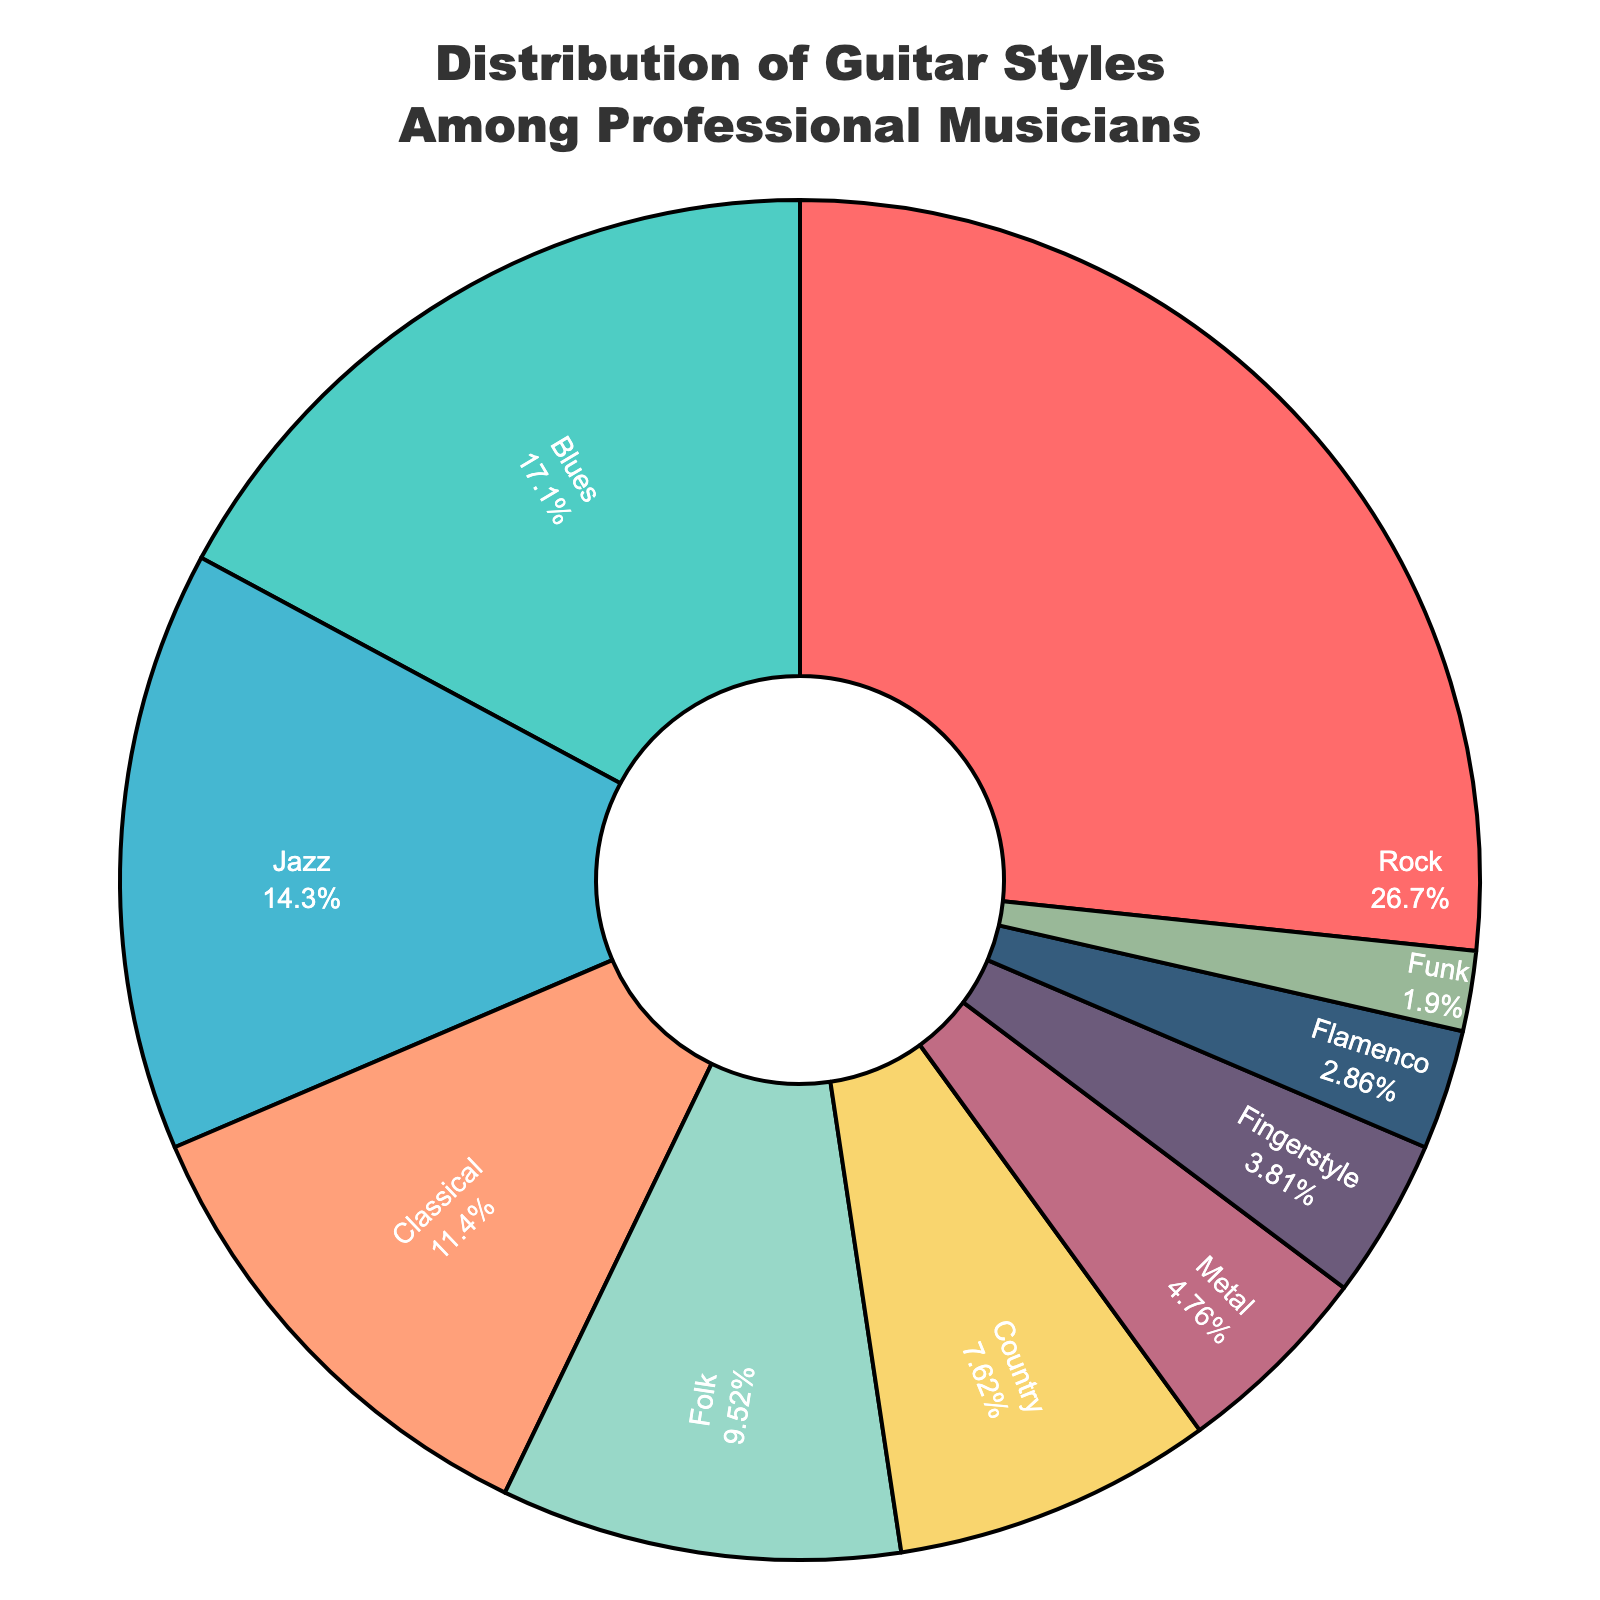What is the most popular guitar style among professional musicians? The most popular guitar style can be identified by finding the largest percentage slice in the pie chart, which is labeled. The slice labeled "Rock" has the largest percentage at 28%.
Answer: Rock Which guitar style has the smallest percentage among professional musicians? To find the guitar style with the smallest percentage, look for the smallest slice in the pie chart and refer to its label. The smallest slice is labeled "Funk" with 2%.
Answer: Funk How much more popular is Rock compared to Metal among professional musicians? First, find the percentages for Rock and Metal. Rock is 28% and Metal is 5%. Subtract the percentage of Metal from Rock: 28% - 5% = 23%.
Answer: 23% What percentage of professional musicians play either Classical or Folk guitar? Find the percentages for Classical and Folk from the pie chart, which are 12% and 10% respectively. Sum these percentages: 12% + 10% = 22%.
Answer: 22% Is Blues or Jazz more popular among professional musicians, and by how much? Look at the pie chart slices for Blues and Jazz. Blues has a percentage of 18% and Jazz has 15%. Subtract the percentage of Jazz from Blues: 18% - 15% = 3%.
Answer: Blues by 3% What is the total percentage of professional musicians who play either Rock, Blues, Jazz, and Classical guitar? Add up the percentages for Rock (28%), Blues (18%), Jazz (15%), and Classical (12%): 28% + 18% + 15% + 12% = 73%.
Answer: 73% How does the popularity of Fingerstyle compare to Metal among professional musicians? Fingerstyle has a percentage of 4% and Metal has 5%. Compare the two percentages: Metal is 1% more popular than Fingerstyle.
Answer: Metal by 1% Which guitar styles have a combined popularity that is less than 10%? Identify the percentages from the pie chart that individually amount to less than 10%. The styles are Metal (5%), Fingerstyle (4%), Flamenco (3%), and Funk (2%). Adding any combination of these: 5% + 4% = 9%, 4% + 3% = 7%, etc., all less than 10%.
Answer: Metal, Fingerstyle, Flamenco, Funk What proportion of the total pie chart is taken up by less common styles (those with percentages below 10%)? Identify the styles that have percentages below 10%: Country (8%), Metal (5%), Fingerstyle (4%), Flamenco (3%), Funk (2%). Sum these percentages: 8% + 5% + 4% + 3% + 2% = 22%.
Answer: 22% Compare the combination of Folk and Country against Jazz in terms of popularity. Which is more popular and by how much? Folk is 10%, Country is 8%, and Jazz is 15%. Add Folk and Country: 10% + 8% = 18%. Compare with Jazz: 18% - 15% = 3%. Folk and Country combined are 3% more popular than Jazz.
Answer: Folk and Country by 3% 